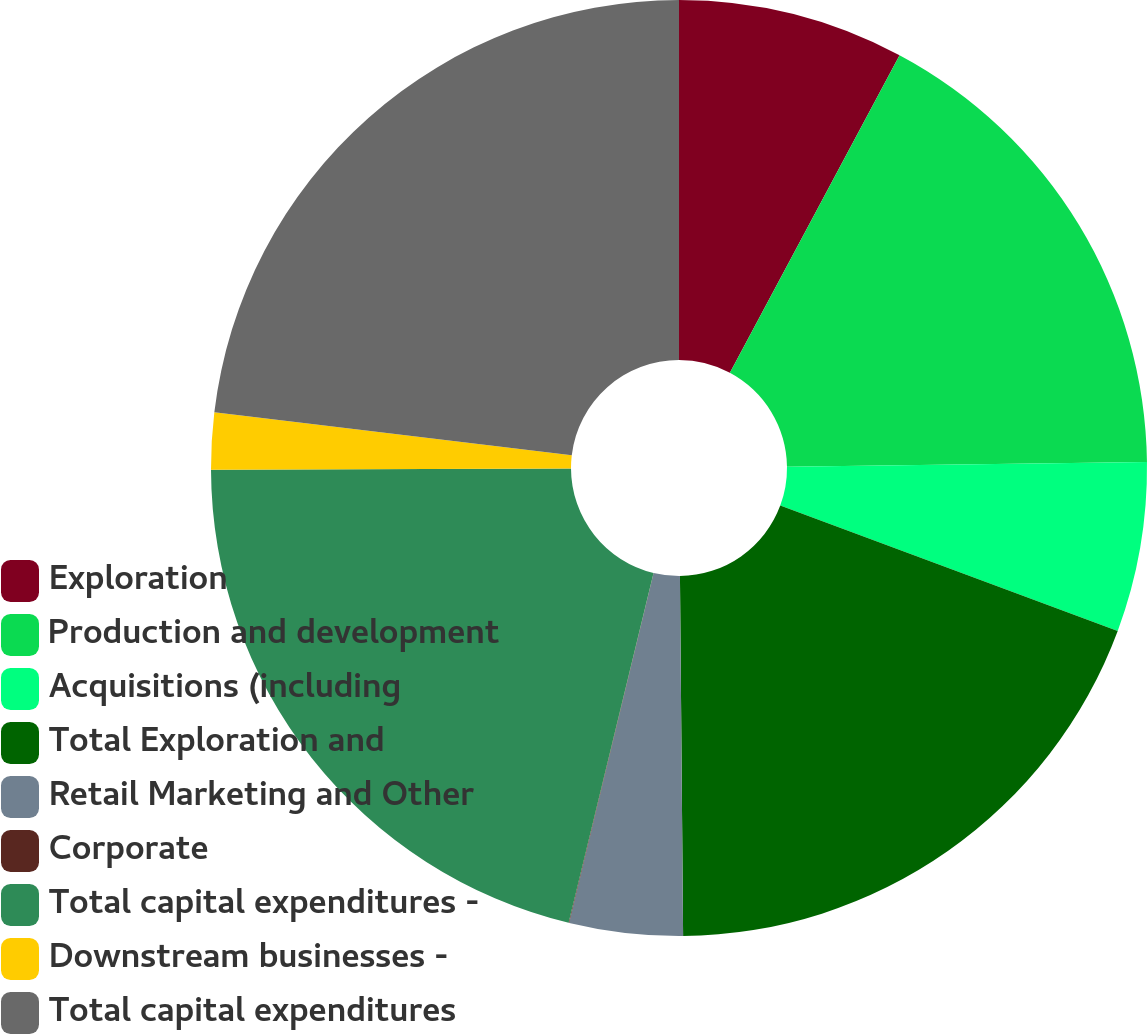Convert chart. <chart><loc_0><loc_0><loc_500><loc_500><pie_chart><fcel>Exploration<fcel>Production and development<fcel>Acquisitions (including<fcel>Total Exploration and<fcel>Retail Marketing and Other<fcel>Corporate<fcel>Total capital expenditures -<fcel>Downstream businesses -<fcel>Total capital expenditures<nl><fcel>7.81%<fcel>16.99%<fcel>5.86%<fcel>19.2%<fcel>3.91%<fcel>0.02%<fcel>21.15%<fcel>1.96%<fcel>23.1%<nl></chart> 